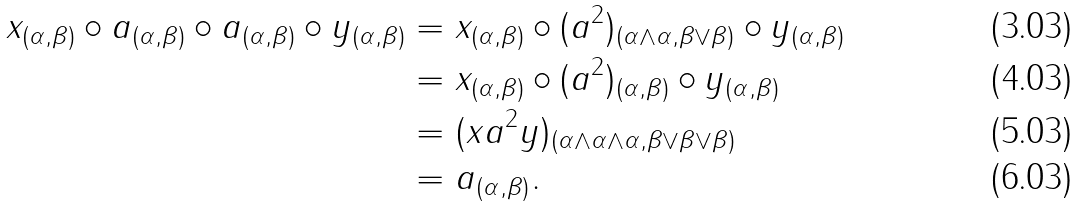Convert formula to latex. <formula><loc_0><loc_0><loc_500><loc_500>x _ { ( \alpha , \beta ) } \circ a _ { ( \alpha , \beta ) } \circ a _ { ( \alpha , \beta ) } \circ y _ { ( \alpha , \beta ) } & = x _ { ( \alpha , \beta ) } \circ ( a ^ { 2 } ) _ { ( \alpha \wedge \alpha , \beta \vee \beta ) } \circ y _ { ( \alpha , \beta ) } \\ & = x _ { ( \alpha , \beta ) } \circ ( a ^ { 2 } ) _ { ( \alpha , \beta ) } \circ y _ { ( \alpha , \beta ) } \\ & = ( x a ^ { 2 } y ) _ { ( \alpha \wedge \alpha \wedge \alpha , \beta \vee \beta \vee \beta ) } \\ & = a _ { ( \alpha , \beta ) } .</formula> 